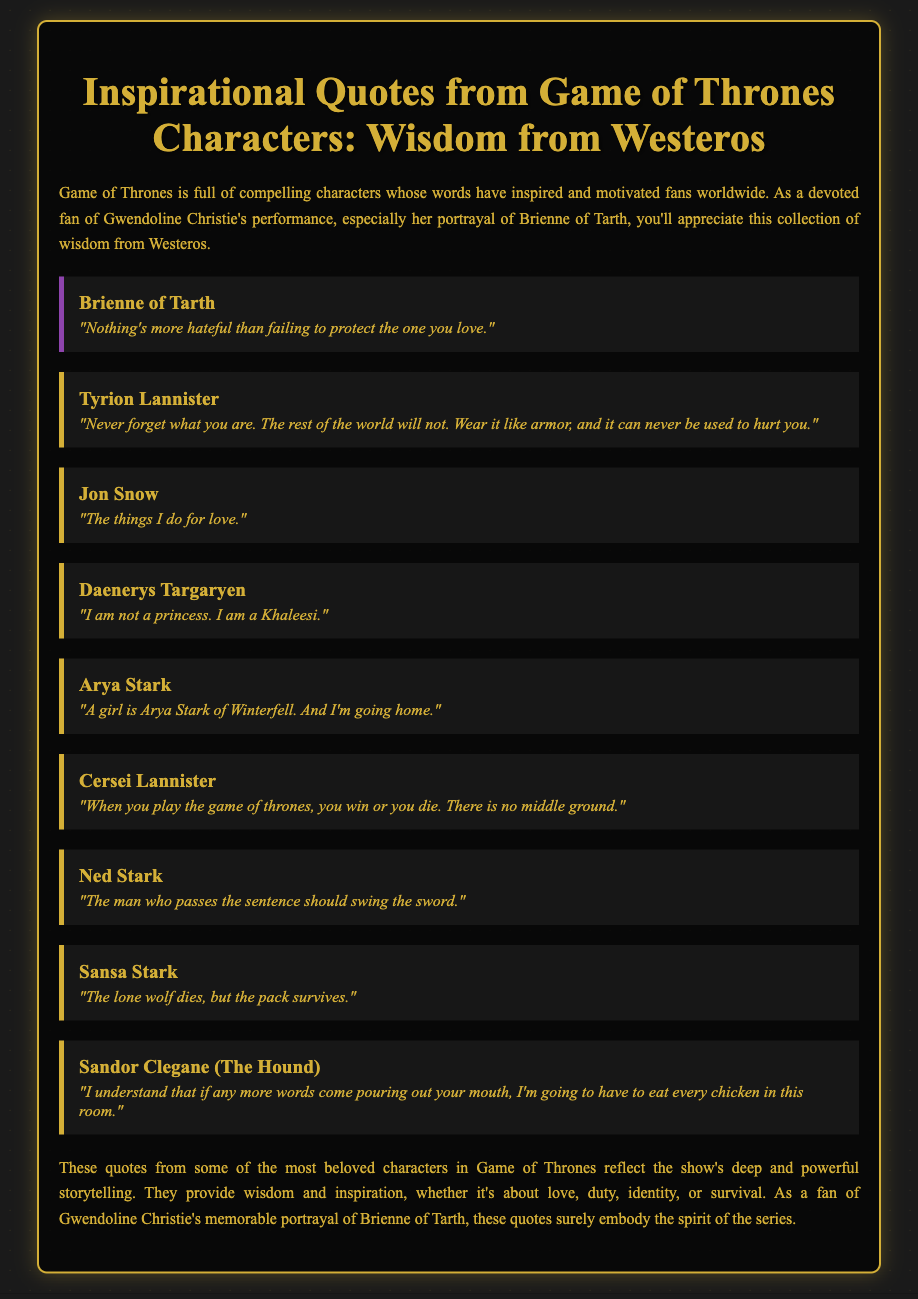What is Brienne of Tarth’s quote? Brienne of Tarth’s quote is about the hatred of failing to protect loved ones.
Answer: "Nothing's more hateful than failing to protect the one you love." Who said "When you play the game of thrones, you win or you die"? This quote is attributed to Cersei Lannister in the document.
Answer: Cersei Lannister How many quotes are attributed to Daenerys Targaryen? There is one quote from Daenerys Targaryen in the document.
Answer: 1 What is the central theme reflected in these quotes? The quotes reflect themes of love, duty, identity, or survival.
Answer: Love, duty, identity, survival Which character is quoted saying about "the lone wolf"? The character quoted about "the lone wolf" is Sansa Stark.
Answer: Sansa Stark 